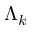Convert formula to latex. <formula><loc_0><loc_0><loc_500><loc_500>\Lambda _ { k }</formula> 